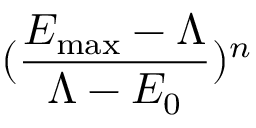Convert formula to latex. <formula><loc_0><loc_0><loc_500><loc_500>( \frac { E _ { \max } - \Lambda } { \Lambda - E _ { 0 } } ) ^ { n }</formula> 